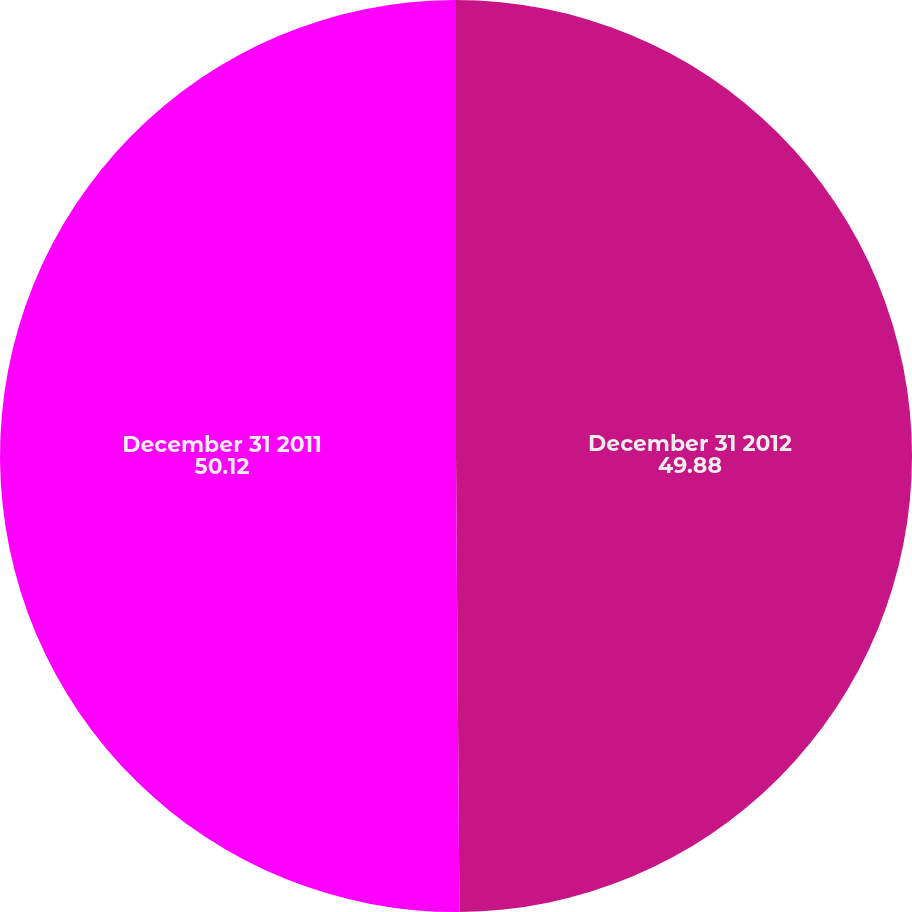<chart> <loc_0><loc_0><loc_500><loc_500><pie_chart><fcel>December 31 2012<fcel>December 31 2011<nl><fcel>49.88%<fcel>50.12%<nl></chart> 